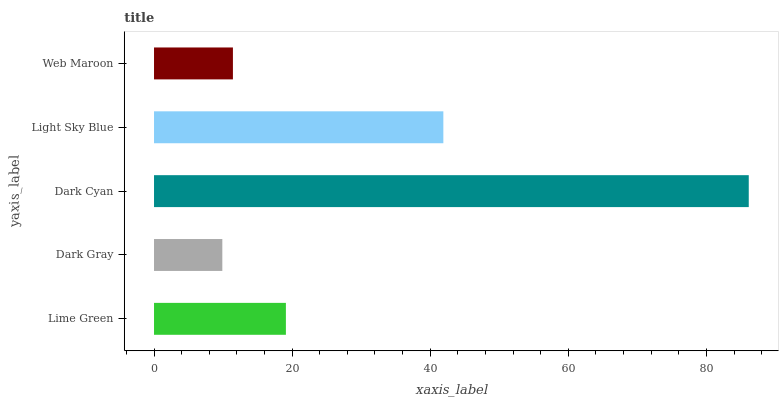Is Dark Gray the minimum?
Answer yes or no. Yes. Is Dark Cyan the maximum?
Answer yes or no. Yes. Is Dark Cyan the minimum?
Answer yes or no. No. Is Dark Gray the maximum?
Answer yes or no. No. Is Dark Cyan greater than Dark Gray?
Answer yes or no. Yes. Is Dark Gray less than Dark Cyan?
Answer yes or no. Yes. Is Dark Gray greater than Dark Cyan?
Answer yes or no. No. Is Dark Cyan less than Dark Gray?
Answer yes or no. No. Is Lime Green the high median?
Answer yes or no. Yes. Is Lime Green the low median?
Answer yes or no. Yes. Is Dark Gray the high median?
Answer yes or no. No. Is Light Sky Blue the low median?
Answer yes or no. No. 